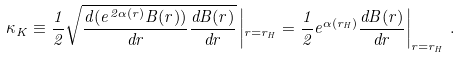Convert formula to latex. <formula><loc_0><loc_0><loc_500><loc_500>\kappa _ { K } \equiv \frac { 1 } { 2 } \sqrt { \frac { d ( e ^ { 2 \alpha ( r ) } B ( r ) ) } { d r } \frac { d B ( r ) } { d r } } \left | _ { r = r _ { H } } = \frac { 1 } { 2 } e ^ { \alpha ( r _ { H } ) } \frac { d B ( r ) } { d r } \right | _ { r = r _ { H } } \, .</formula> 